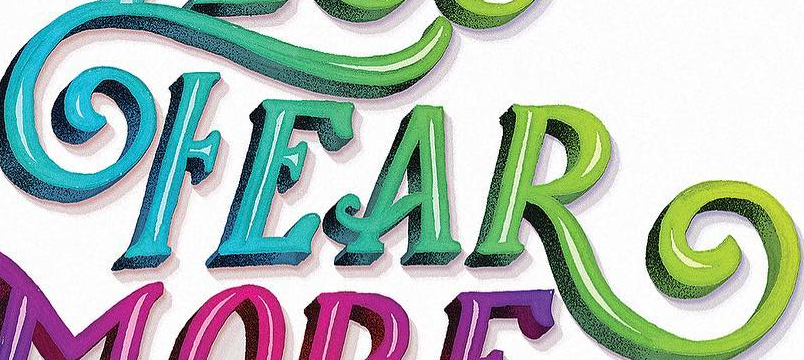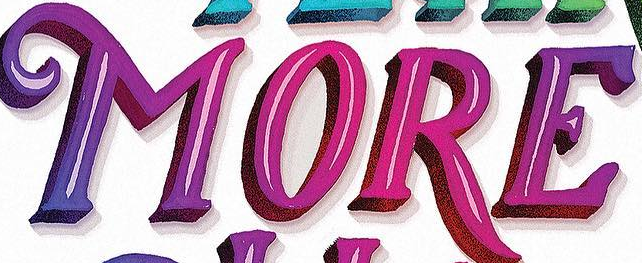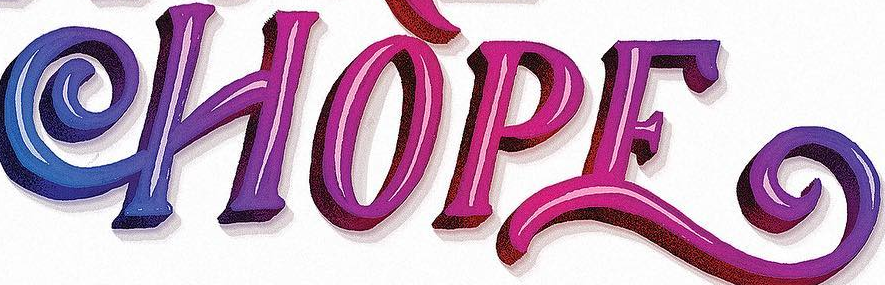What words can you see in these images in sequence, separated by a semicolon? FEAR; MORE; HOPE 